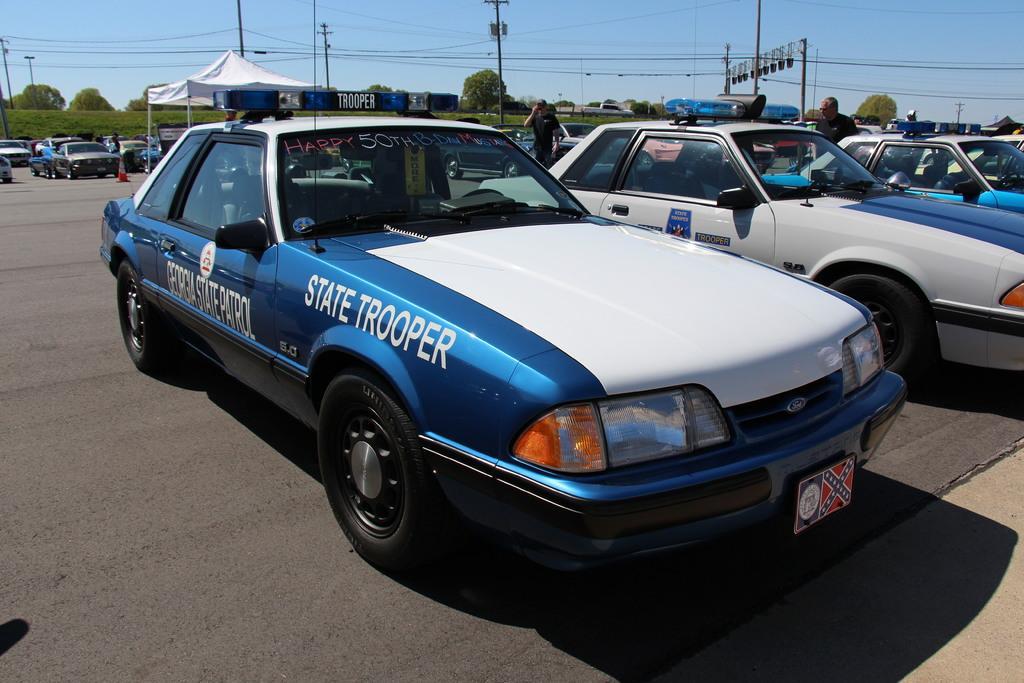Please provide a concise description of this image. In this image I can see many cars on the road and also few people are standing. On the left side there is a tent. In the background there are many trees and poles along with the wires. At the top of the image I can see the sky. 